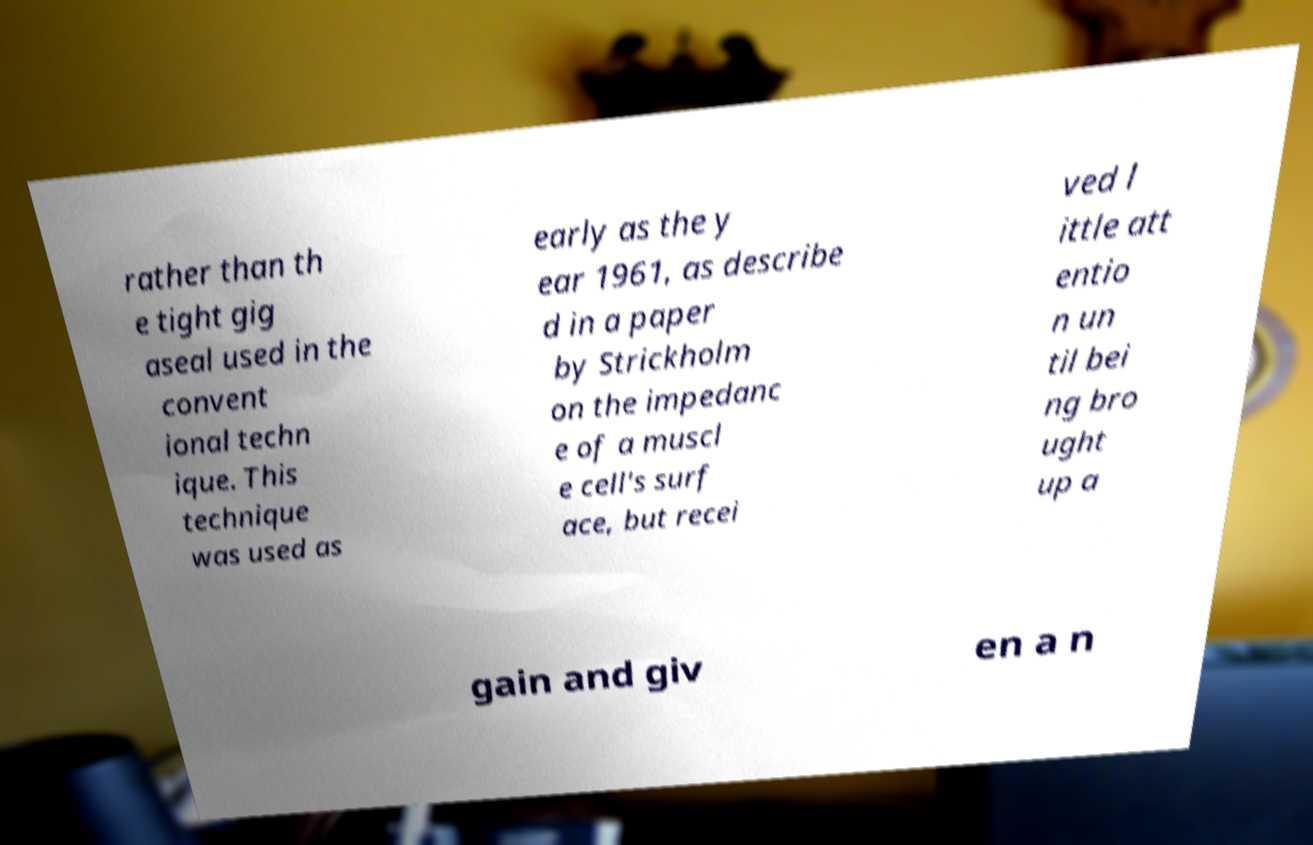Could you extract and type out the text from this image? rather than th e tight gig aseal used in the convent ional techn ique. This technique was used as early as the y ear 1961, as describe d in a paper by Strickholm on the impedanc e of a muscl e cell's surf ace, but recei ved l ittle att entio n un til bei ng bro ught up a gain and giv en a n 